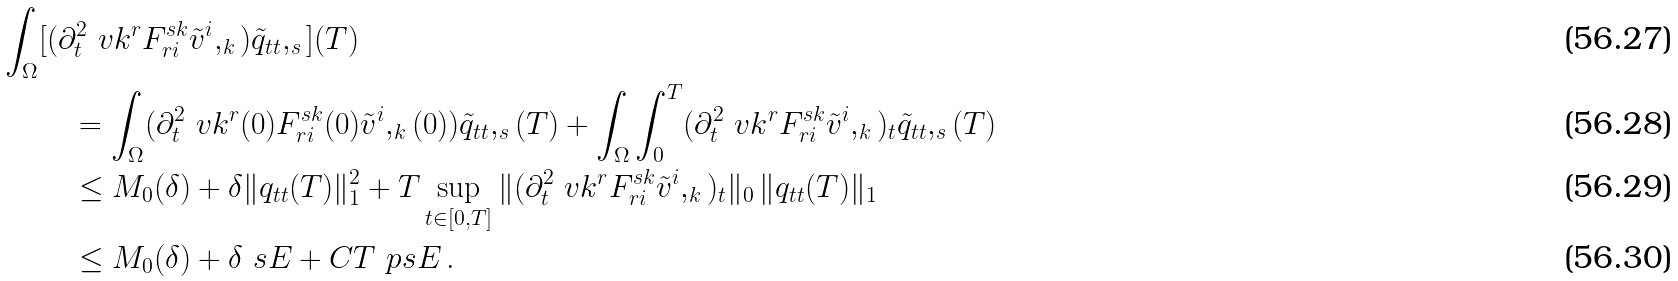<formula> <loc_0><loc_0><loc_500><loc_500>\int _ { \Omega } & [ ( \partial _ { t } ^ { 2 } \ v k ^ { r } F ^ { s k } _ { r i } \tilde { v } ^ { i } , _ { k } ) \tilde { q } _ { t t } , _ { s } ] ( T ) \\ & \quad = \int _ { \Omega } ( \partial _ { t } ^ { 2 } \ v k ^ { r } ( 0 ) F ^ { s k } _ { r i } ( 0 ) \tilde { v } ^ { i } , _ { k } ( 0 ) ) \tilde { q } _ { t t } , _ { s } ( T ) + \int _ { \Omega } \int _ { 0 } ^ { T } ( \partial _ { t } ^ { 2 } \ v k ^ { r } F ^ { s k } _ { r i } \tilde { v } ^ { i } , _ { k } ) _ { t } \tilde { q } _ { t t } , _ { s } ( T ) \\ & \quad \leq M _ { 0 } ( \delta ) + \delta \| q _ { t t } ( T ) \| _ { 1 } ^ { 2 } + T \sup _ { t \in [ 0 , T ] } \| ( \partial _ { t } ^ { 2 } \ v k ^ { r } F ^ { s k } _ { r i } \tilde { v } ^ { i } , _ { k } ) _ { t } \| _ { 0 } \, \| q _ { t t } ( T ) \| _ { 1 } \\ & \quad \leq M _ { 0 } ( \delta ) + \delta \ s E + C T \ p s E \, .</formula> 